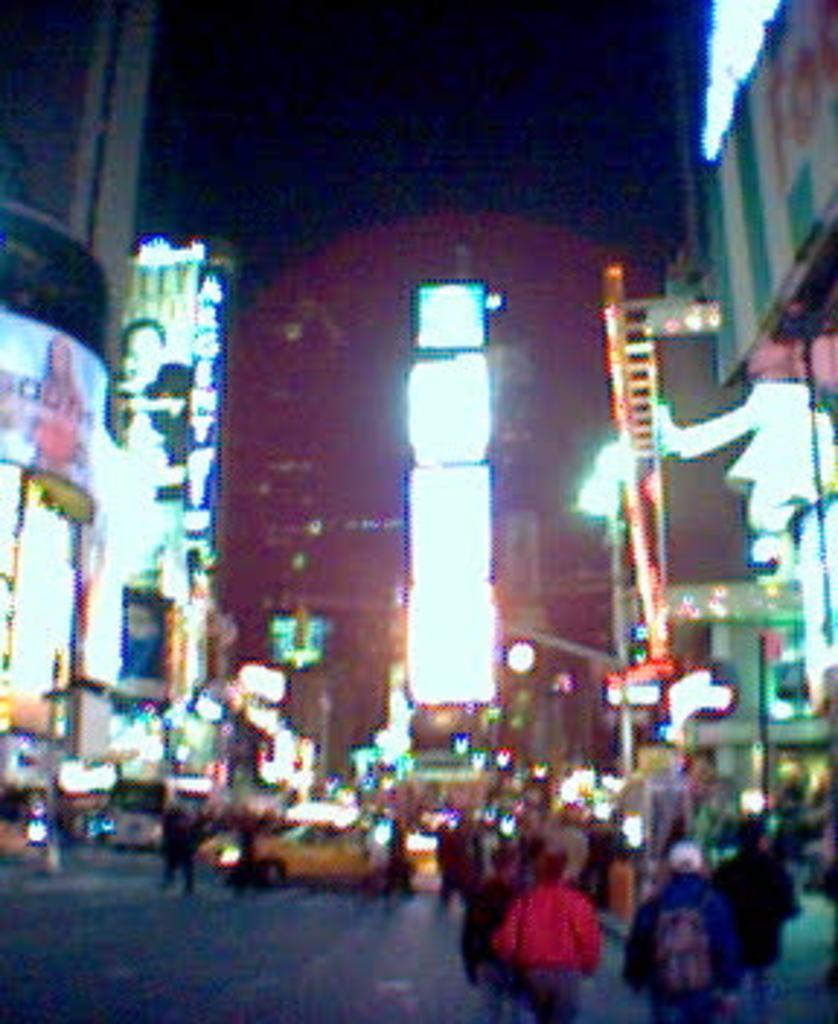Could you give a brief overview of what you see in this image? This picture is clicked outside the city. At the bottom, we see the road. On the right side, we see the people are walking on the road. In the middle, we see a yellow car and beside that, we see the people are standing. On the left side, we see the buildings and a pole. In the background, we see the buildings, lights and the hoarding boards. At the top, we see the sky. This picture is clicked in the dark. This picture is blurred. 